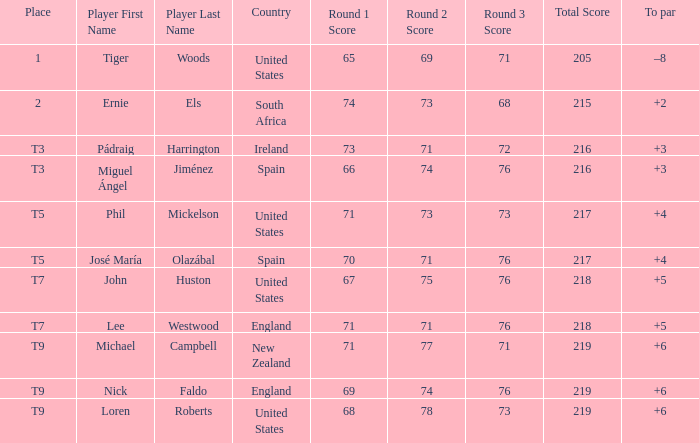Can you parse all the data within this table? {'header': ['Place', 'Player First Name', 'Player Last Name', 'Country', 'Round 1 Score', 'Round 2 Score', 'Round 3 Score', 'Total Score', 'To par'], 'rows': [['1', 'Tiger', 'Woods', 'United States', '65', '69', '71', '205', '–8'], ['2', 'Ernie', 'Els', 'South Africa', '74', '73', '68', '215', '+2'], ['T3', 'Pádraig', 'Harrington', 'Ireland', '73', '71', '72', '216', '+3'], ['T3', 'Miguel Ángel', 'Jiménez', 'Spain', '66', '74', '76', '216', '+3'], ['T5', 'Phil', 'Mickelson', 'United States', '71', '73', '73', '217', '+4'], ['T5', 'José María', 'Olazábal', 'Spain', '70', '71', '76', '217', '+4'], ['T7', 'John', 'Huston', 'United States', '67', '75', '76', '218', '+5'], ['T7', 'Lee', 'Westwood', 'England', '71', '71', '76', '218', '+5'], ['T9', 'Michael', 'Campbell', 'New Zealand', '71', '77', '71', '219', '+6'], ['T9', 'Nick', 'Faldo', 'England', '69', '74', '76', '219', '+6'], ['T9', 'Loren', 'Roberts', 'United States', '68', '78', '73', '219', '+6']]} What is Player, when Place is "1"? Tiger Woods. 